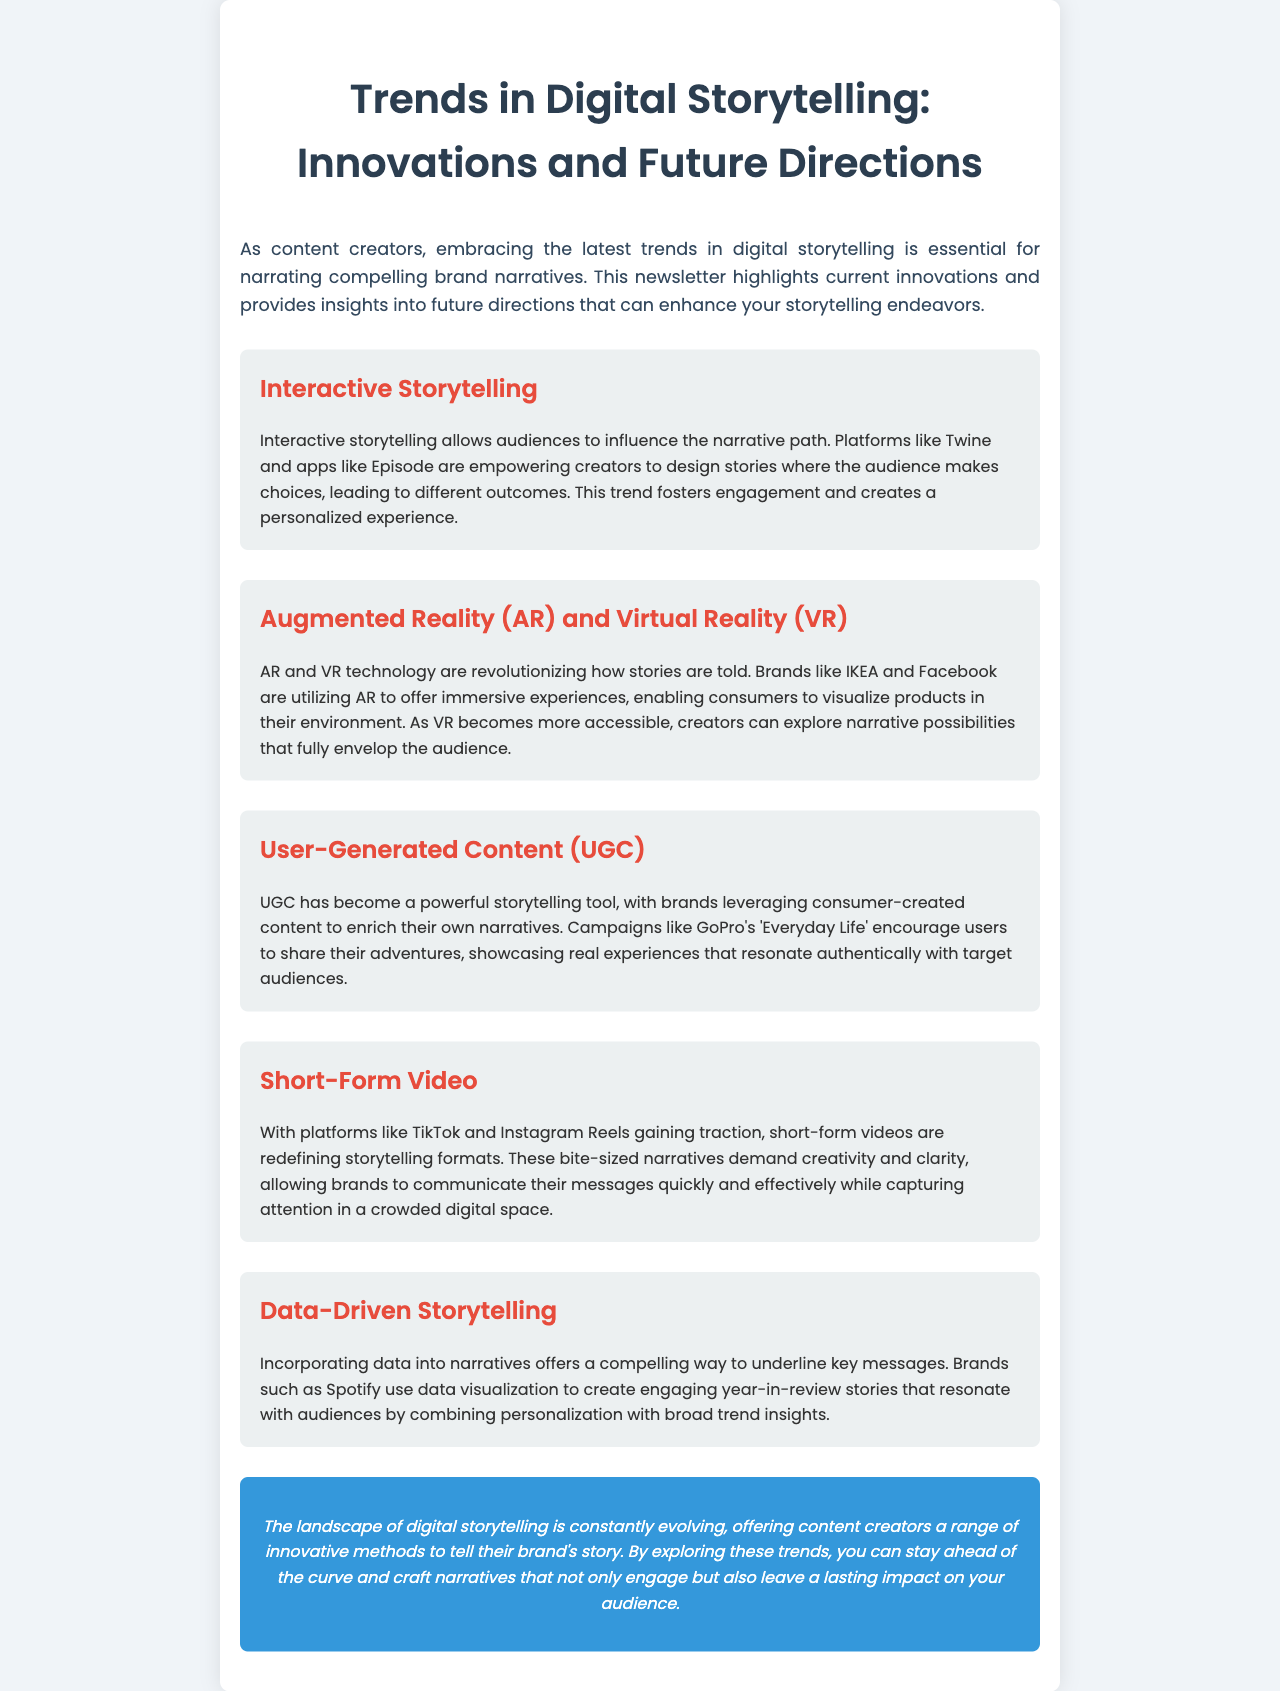What is the title of the newsletter? The title of the newsletter is clearly indicated at the top of the document.
Answer: Trends in Digital Storytelling: Innovations and Future Directions What trend involves audience choices? The document describes a trend where the audience influences the narrative, highlighting interactive elements.
Answer: Interactive Storytelling Which brands utilize Augmented Reality technology according to the newsletter? Several brands are mentioned in relation to AR technology; the document specifies which ones.
Answer: IKEA and Facebook What type of content is highlighted in UGC? The document discusses user-generated content and gives examples of how it's used in storytelling.
Answer: Consumer-created content What platform is known for short-form video storytelling? The newsletter mentions a specific platform that has gained popularity for its short video format.
Answer: TikTok Which storytelling method uses data visualization? The newsletter refers to a brand that effectively incorporates data into narratives for storytelling.
Answer: Spotify What color is used for the conclusion section? The document describes the visual characteristics of the conclusion, including its background color.
Answer: Blue How many trends are discussed in the newsletter? The document presents a list of trends, which can be counted for an accurate answer.
Answer: Five 